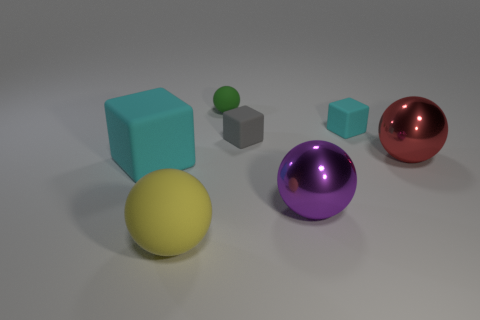Is the number of cyan rubber blocks to the right of the big purple shiny object the same as the number of things left of the big yellow matte thing?
Ensure brevity in your answer.  Yes. There is a tiny green thing that is the same shape as the big yellow object; what material is it?
Your response must be concise. Rubber. Is there a shiny object behind the cyan thing to the left of the large matte object that is to the right of the big cyan rubber cube?
Make the answer very short. Yes. Does the cyan rubber object that is behind the big red thing have the same shape as the large purple thing in front of the gray block?
Keep it short and to the point. No. Are there more rubber balls that are in front of the small cyan block than large rubber blocks?
Provide a short and direct response. No. What number of things are either big cyan blocks or green balls?
Keep it short and to the point. 2. What is the color of the tiny sphere?
Give a very brief answer. Green. How many other things are there of the same color as the large rubber sphere?
Offer a very short reply. 0. There is a big rubber sphere; are there any cubes on the left side of it?
Your response must be concise. Yes. What color is the tiny matte object that is behind the cyan matte block to the right of the cyan thing that is in front of the red metallic ball?
Provide a short and direct response. Green. 